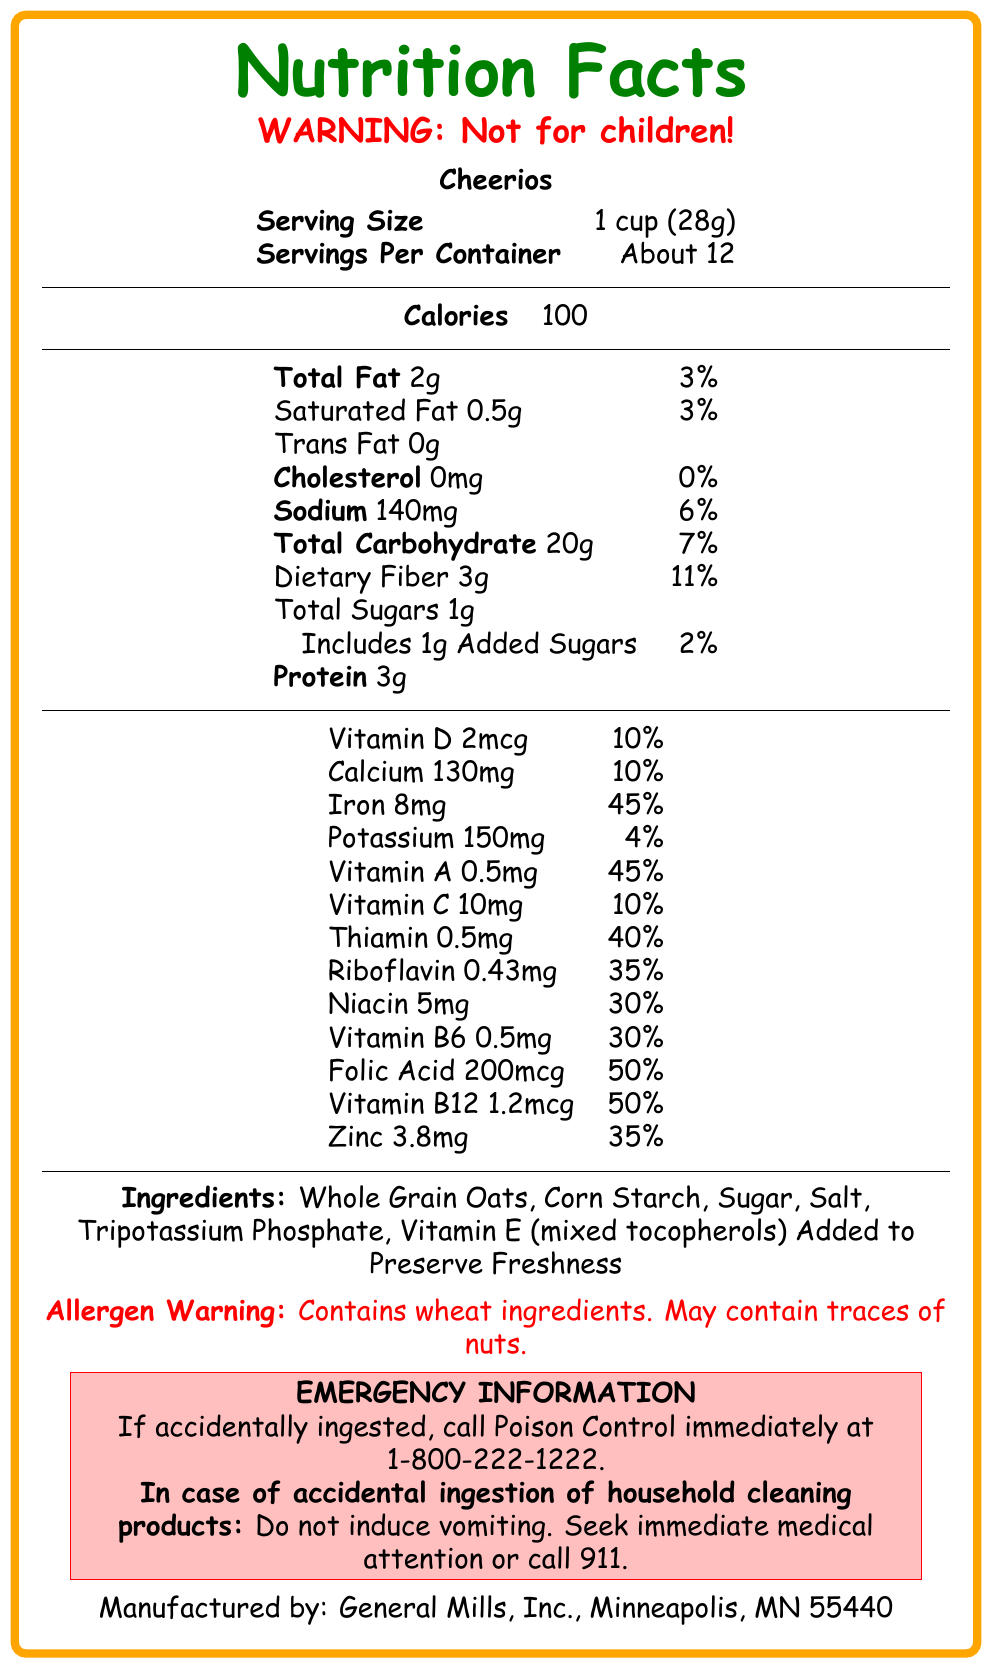what is the serving size? The serving size is displayed as "1 cup (28g)" in the document.
Answer: 1 cup (28g) how many servings are in one container? The document states "Servings Per Container: About 12".
Answer: About 12 how many calories are there per serving? The document lists "Calories: 100" per serving.
Answer: 100 what is the total fat content per serving? The document indicates "Total Fat: 2g".
Answer: 2g what is the cholesterol content per serving? The document shows "Cholesterol: 0mg".
Answer: 0mg how much dietary fiber is in one serving? According to the document, the dietary fiber content is "3g".
Answer: 3g how much added sugars does one serving contain? The document states that there are "Includes 1g Added Sugars".
Answer: 1g which vitamin has the highest daily value percentage in this cereal? A. Vitamin D B. Vitamin A C. Vitamin B12 "Folic Acid" and "Vitamin B12" both have the highest daily value percentage at "50%".
Answer: C what is the allergen warning given in the document? The document states, "Allergen Warning: Contains wheat ingredients. May contain traces of nuts."
Answer: Contains wheat ingredients. May contain traces of nuts. the emergency information advises not to do something in case of accidental ingestion of household cleaning products. What is it? The document advises: "Do not induce vomiting. Seek immediate medical attention or call 911."
Answer: Do not induce vomiting what is the manufacturer of this cereal? The bottom of the document states this is manufactured by "General Mills, Inc., Minneapolis, MN 55440".
Answer: General Mills, Inc., Minneapolis, MN 55440 what is the percent daily value of sodium per serving? The document lists the sodium percent daily value as "6%".
Answer: 6% does the cereal contain trans fat? The document lists "Trans Fat: 0g", indicating there is no trans fat.
Answer: No summarize the main point of the document. The document contains information typically found on a nutrition label, including the nutritional content per serving, ingredient list, allergen warning, and emergency contact info.
Answer: This document is a Nutrition Facts label for Cheerios cereal, providing details on serving size, nutritional content, ingredient list, allergen warnings, and emergency information for accidental ingestion. can you calculate how many grams of protein you would consume if you ate the entire container? The document does not provide enough data to calculate the total protein for the entire container as the exact number of servings per container is approximated rather than exact.
Answer: Not enough information 